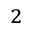<formula> <loc_0><loc_0><loc_500><loc_500>^ { 2 }</formula> 